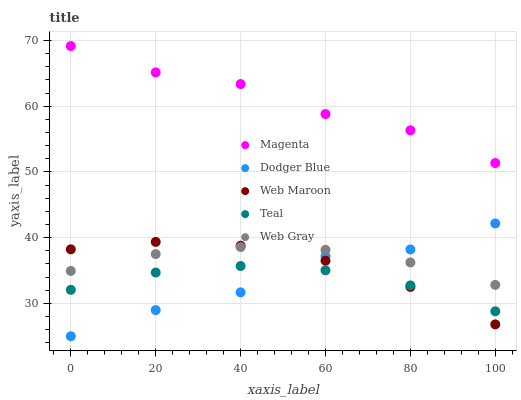Does Teal have the minimum area under the curve?
Answer yes or no. Yes. Does Magenta have the maximum area under the curve?
Answer yes or no. Yes. Does Web Gray have the minimum area under the curve?
Answer yes or no. No. Does Web Gray have the maximum area under the curve?
Answer yes or no. No. Is Web Gray the smoothest?
Answer yes or no. Yes. Is Dodger Blue the roughest?
Answer yes or no. Yes. Is Magenta the smoothest?
Answer yes or no. No. Is Magenta the roughest?
Answer yes or no. No. Does Dodger Blue have the lowest value?
Answer yes or no. Yes. Does Web Gray have the lowest value?
Answer yes or no. No. Does Magenta have the highest value?
Answer yes or no. Yes. Does Web Gray have the highest value?
Answer yes or no. No. Is Teal less than Magenta?
Answer yes or no. Yes. Is Magenta greater than Web Gray?
Answer yes or no. Yes. Does Dodger Blue intersect Web Gray?
Answer yes or no. Yes. Is Dodger Blue less than Web Gray?
Answer yes or no. No. Is Dodger Blue greater than Web Gray?
Answer yes or no. No. Does Teal intersect Magenta?
Answer yes or no. No. 